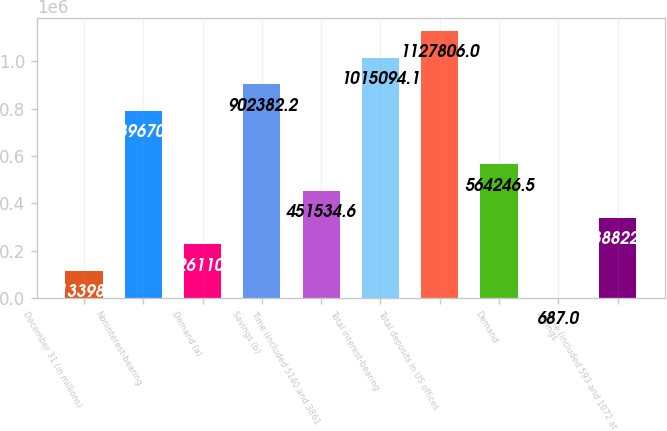Convert chart to OTSL. <chart><loc_0><loc_0><loc_500><loc_500><bar_chart><fcel>December 31 (in millions)<fcel>Noninterest-bearing<fcel>Demand (a)<fcel>Savings (b)<fcel>Time (included 5140 and 3861<fcel>Total interest-bearing<fcel>Total deposits in US offices<fcel>Demand<fcel>Savings<fcel>Time (included 593 and 1072 at<nl><fcel>113399<fcel>789670<fcel>226111<fcel>902382<fcel>451535<fcel>1.01509e+06<fcel>1.12781e+06<fcel>564246<fcel>687<fcel>338823<nl></chart> 